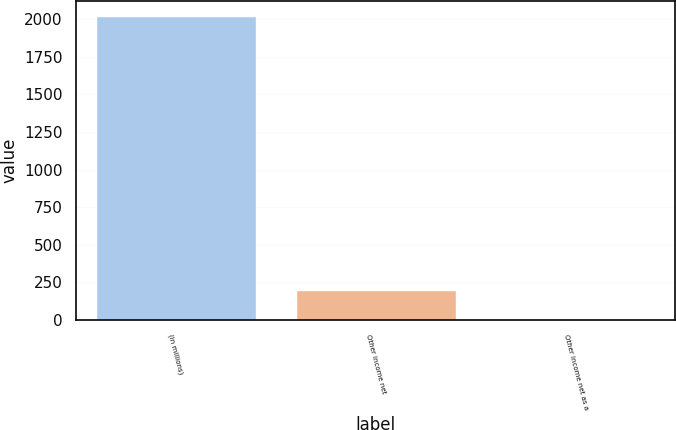Convert chart to OTSL. <chart><loc_0><loc_0><loc_500><loc_500><bar_chart><fcel>(in millions)<fcel>Other income net<fcel>Other income net as a<nl><fcel>2018<fcel>202.25<fcel>0.5<nl></chart> 